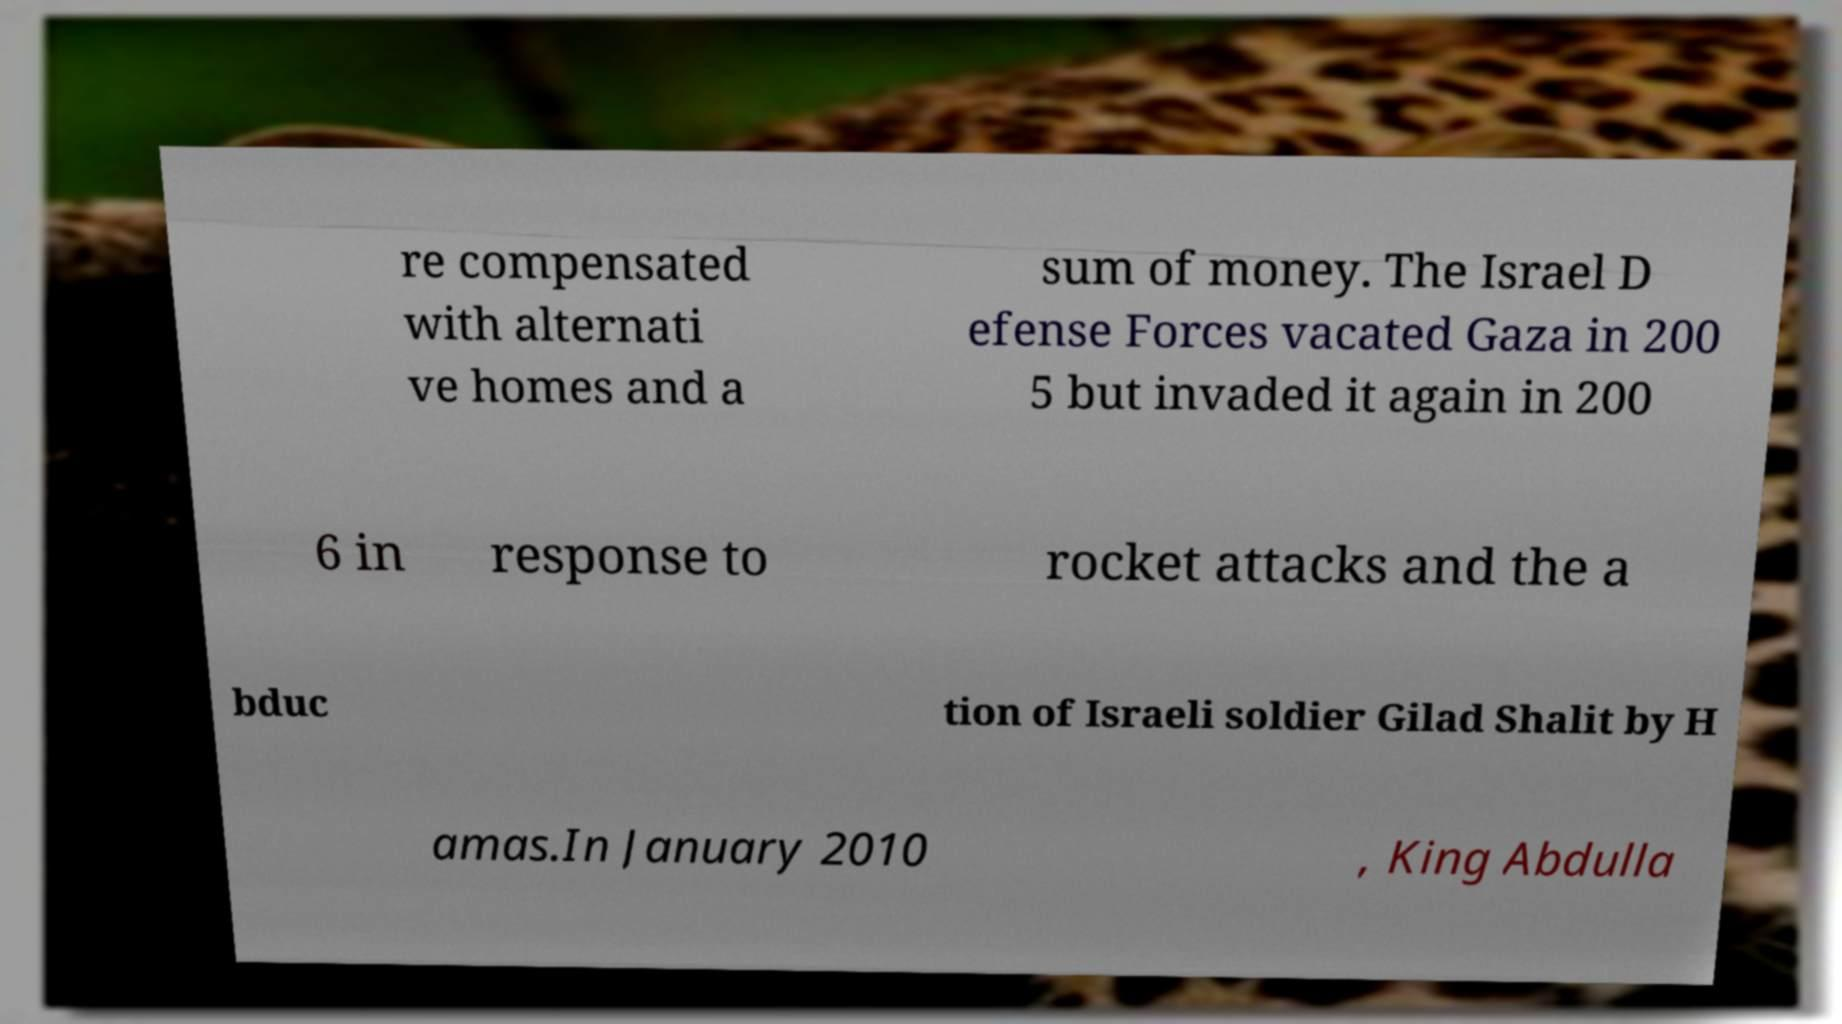What messages or text are displayed in this image? I need them in a readable, typed format. re compensated with alternati ve homes and a sum of money. The Israel D efense Forces vacated Gaza in 200 5 but invaded it again in 200 6 in response to rocket attacks and the a bduc tion of Israeli soldier Gilad Shalit by H amas.In January 2010 , King Abdulla 